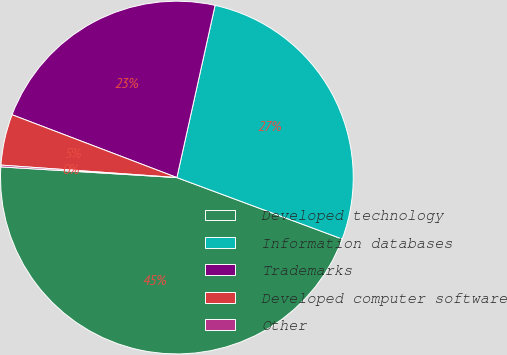Convert chart to OTSL. <chart><loc_0><loc_0><loc_500><loc_500><pie_chart><fcel>Developed technology<fcel>Information databases<fcel>Trademarks<fcel>Developed computer software<fcel>Other<nl><fcel>45.3%<fcel>27.19%<fcel>22.68%<fcel>4.67%<fcel>0.16%<nl></chart> 